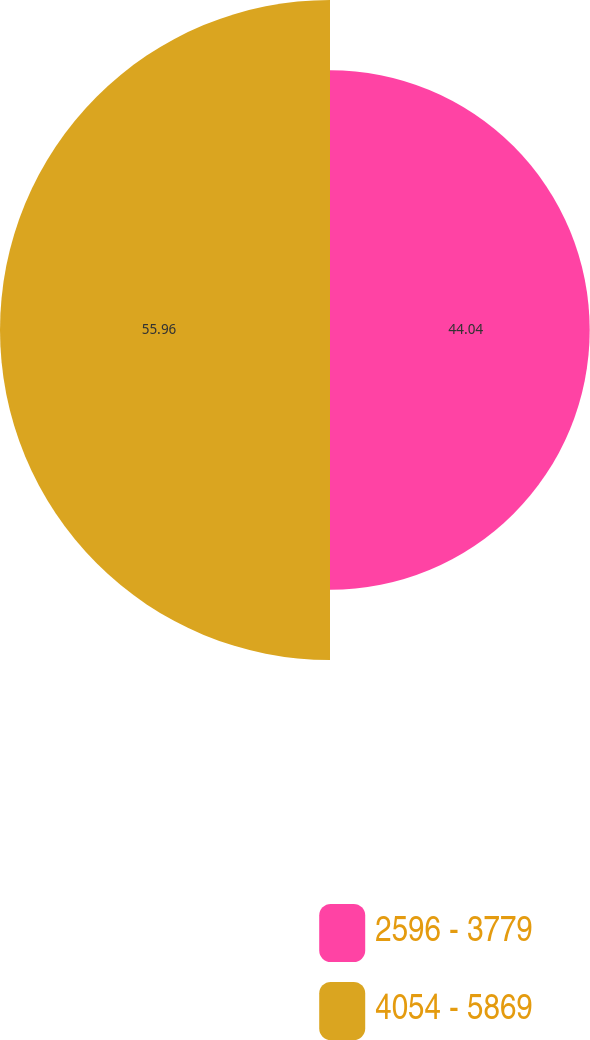Convert chart to OTSL. <chart><loc_0><loc_0><loc_500><loc_500><pie_chart><fcel>2596 - 3779<fcel>4054 - 5869<nl><fcel>44.04%<fcel>55.96%<nl></chart> 